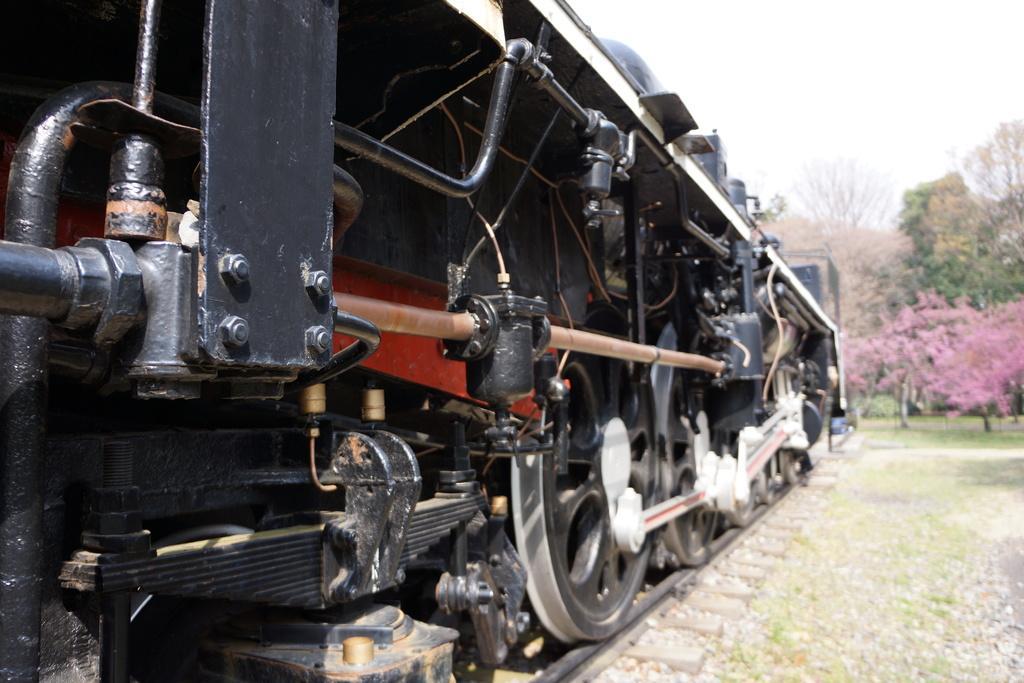Please provide a concise description of this image. In this image I can see on the left side it is a train engine. On the right side there are trees, at the top it is the sky. 